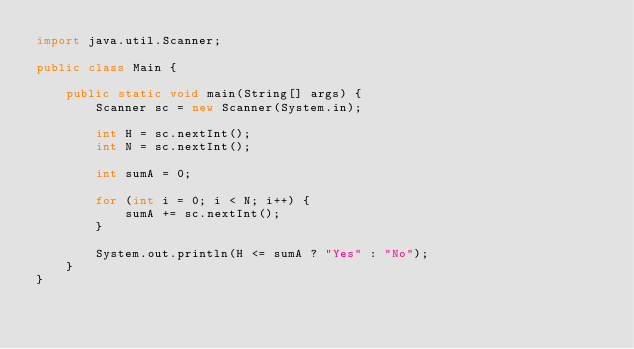<code> <loc_0><loc_0><loc_500><loc_500><_Java_>import java.util.Scanner;

public class Main {

    public static void main(String[] args) {
        Scanner sc = new Scanner(System.in);

        int H = sc.nextInt();
        int N = sc.nextInt();

        int sumA = 0;

        for (int i = 0; i < N; i++) {
            sumA += sc.nextInt();
        }

        System.out.println(H <= sumA ? "Yes" : "No");
    }
}
</code> 